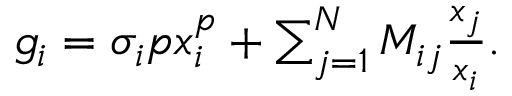<formula> <loc_0><loc_0><loc_500><loc_500>\begin{array} { r } { g _ { i } = \sigma _ { i } p x _ { i } ^ { p } + \sum _ { j = 1 } ^ { N } M _ { i j } \frac { x _ { j } } { x _ { i } } . } \end{array}</formula> 